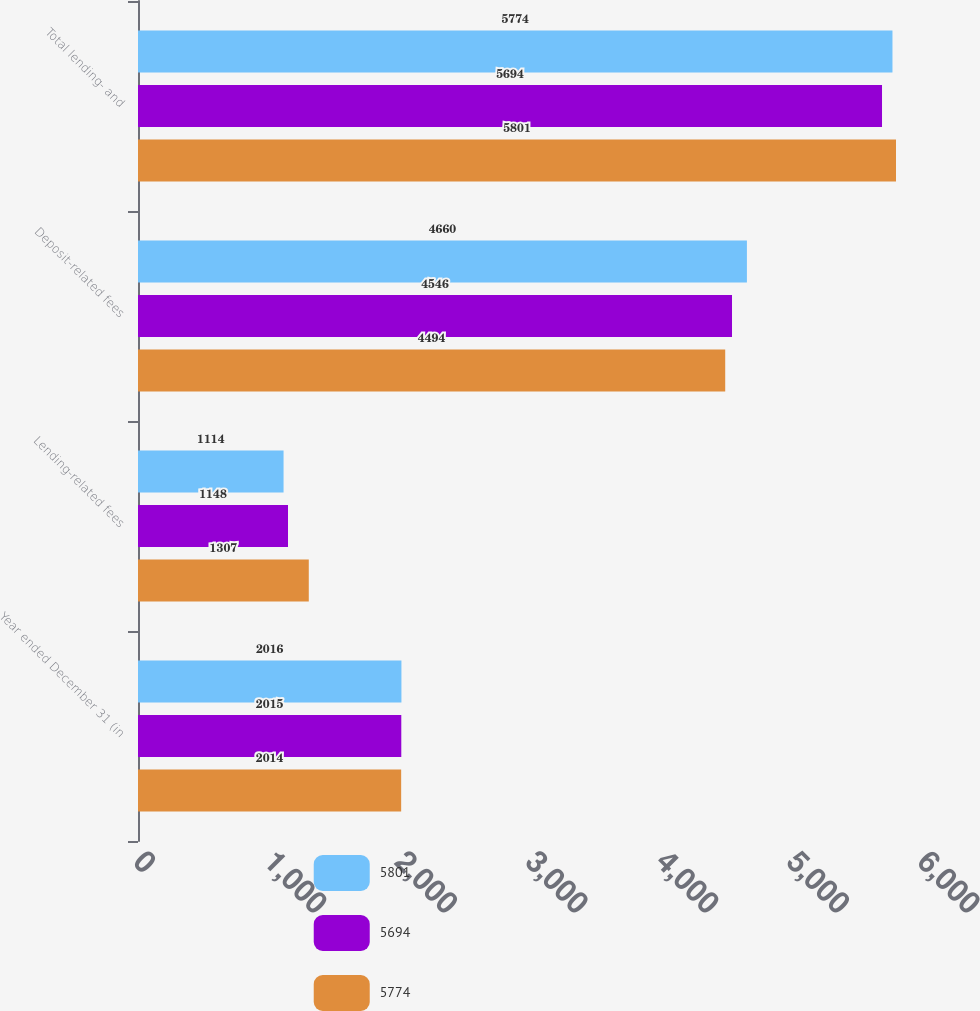<chart> <loc_0><loc_0><loc_500><loc_500><stacked_bar_chart><ecel><fcel>Year ended December 31 (in<fcel>Lending-related fees<fcel>Deposit-related fees<fcel>Total lending- and<nl><fcel>5801<fcel>2016<fcel>1114<fcel>4660<fcel>5774<nl><fcel>5694<fcel>2015<fcel>1148<fcel>4546<fcel>5694<nl><fcel>5774<fcel>2014<fcel>1307<fcel>4494<fcel>5801<nl></chart> 